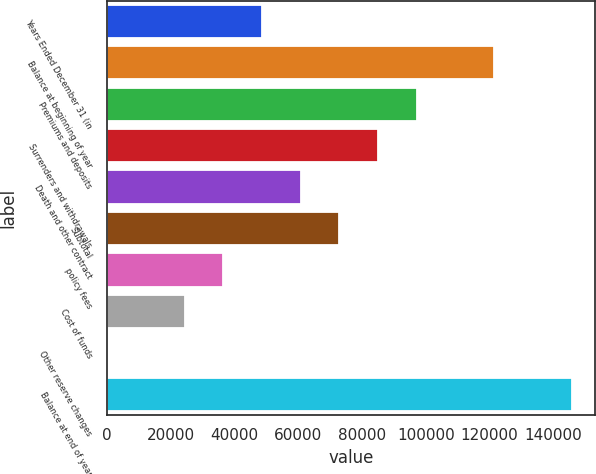Convert chart to OTSL. <chart><loc_0><loc_0><loc_500><loc_500><bar_chart><fcel>Years Ended December 31 (in<fcel>Balance at beginning of year<fcel>Premiums and deposits<fcel>Surrenders and withdrawals<fcel>Death and other contract<fcel>Subtotal<fcel>policy fees<fcel>Cost of funds<fcel>Other reserve changes<fcel>Balance at end of year<nl><fcel>48701.8<fcel>121474<fcel>97216.6<fcel>85087.9<fcel>60830.5<fcel>72959.2<fcel>36573.1<fcel>24444.4<fcel>187<fcel>145731<nl></chart> 